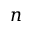Convert formula to latex. <formula><loc_0><loc_0><loc_500><loc_500>n</formula> 